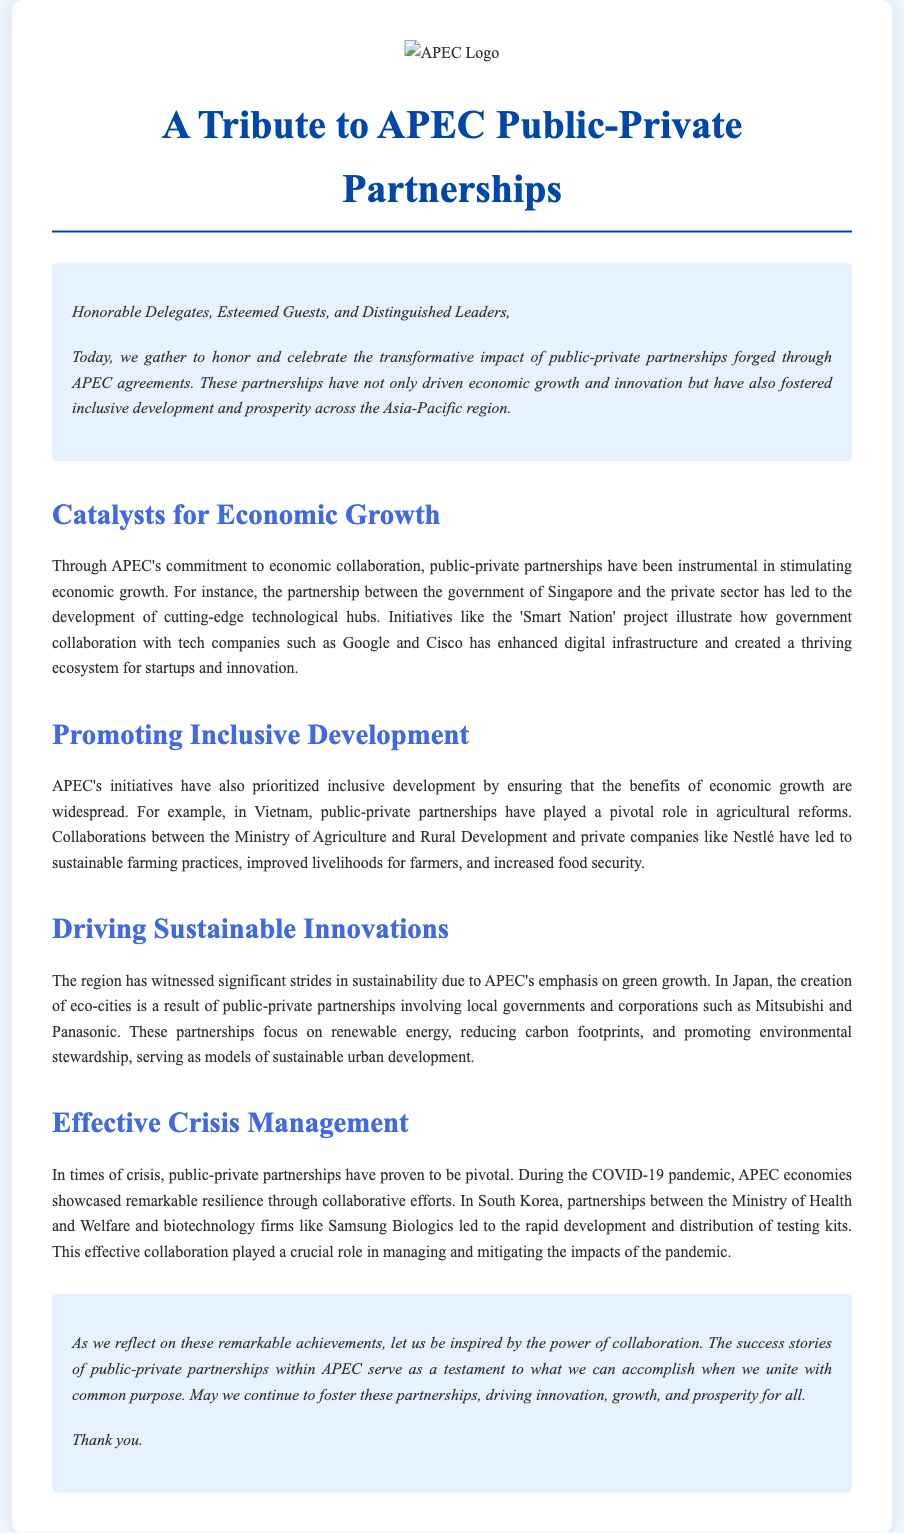What is the primary theme of the eulogy? The eulogy focuses on the impact of public-private partnerships fostered through APEC agreements.
Answer: public-private partnerships Which project in Singapore exemplifies public-private partnership? The eulogy mentions the 'Smart Nation' project as an example.
Answer: 'Smart Nation' What significant role did public-private partnerships play in Vietnam? The eulogy highlights their impact on agricultural reforms and food security.
Answer: agricultural reforms Which companies are mentioned as partners in Japan's eco-cities? The eulogy names Mitsubishi and Panasonic as involved in these partnerships.
Answer: Mitsubishi and Panasonic During which crisis did South Korea's partnerships notably contribute? The eulogy refers to the COVID-19 pandemic as the relevant crisis.
Answer: COVID-19 pandemic What is the overall message of the eulogy regarding collaboration? The message emphasizes the power of collaboration in achieving common goals.
Answer: power of collaboration In which region is the transformative impact of APEC agreements particularly noted? The eulogy specifies that the Asia-Pacific region has benefitted significantly.
Answer: Asia-Pacific region What was a key contribution of public-private partnerships in South Korea? The eulogy states that they led to the rapid development of testing kits during the pandemic.
Answer: rapid development of testing kits 